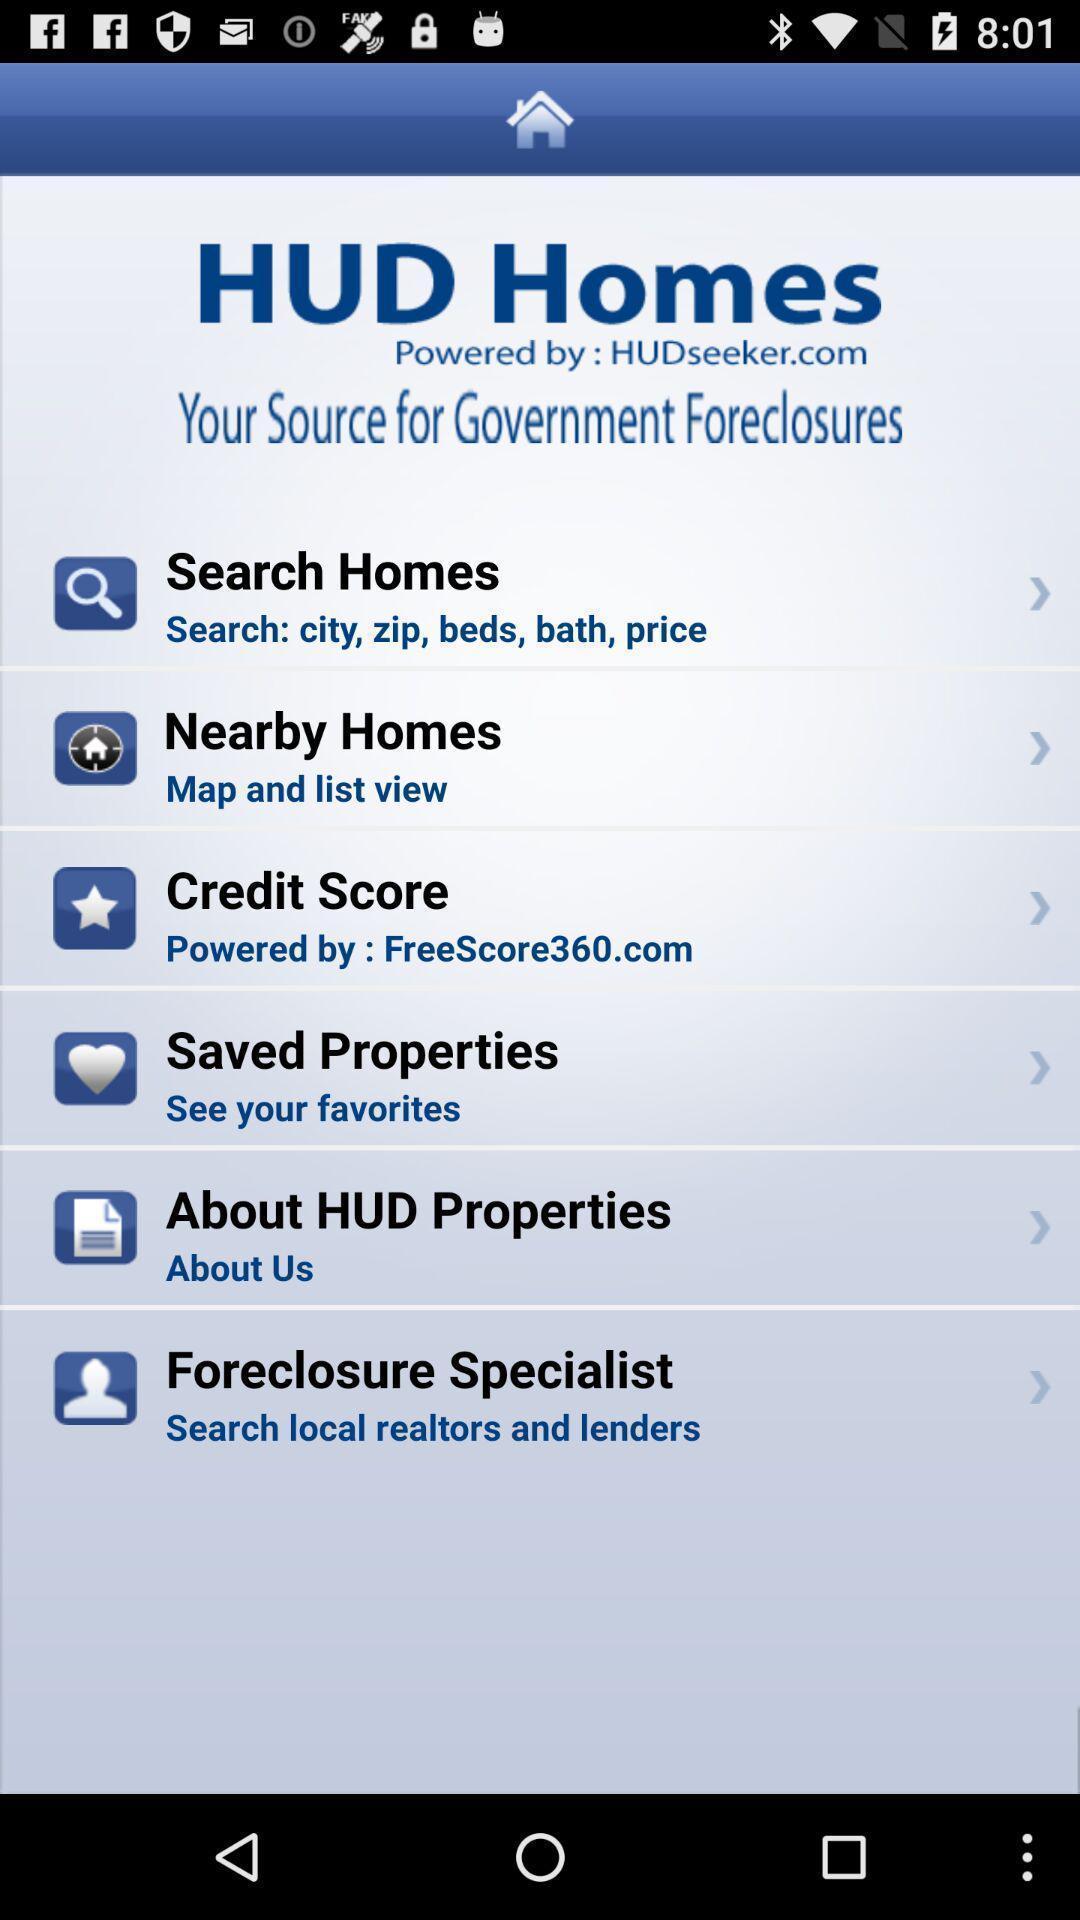Give me a summary of this screen capture. Page showing multiple options. 